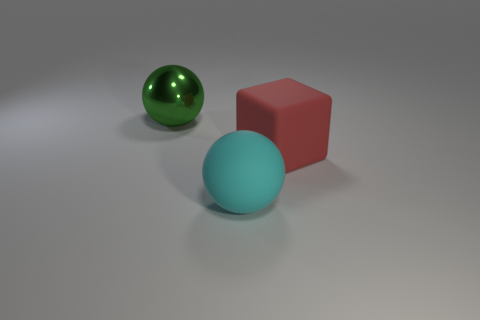There is another red object that is the same size as the metallic thing; what material is it?
Your response must be concise. Rubber. Are there more tiny blue shiny blocks than red blocks?
Your answer should be very brief. No. What number of other objects are there of the same color as the large matte cube?
Give a very brief answer. 0. What number of large balls are in front of the rubber cube and behind the large rubber block?
Offer a terse response. 0. Is there anything else that is the same size as the green shiny thing?
Your answer should be very brief. Yes. Are there more large things that are to the left of the large cyan object than large cyan things that are behind the red matte thing?
Offer a very short reply. Yes. There is a ball that is left of the rubber sphere; what is its material?
Provide a short and direct response. Metal. There is a red object; is its shape the same as the thing in front of the red cube?
Your answer should be compact. No. How many large objects are behind the ball that is on the right side of the large ball that is behind the red block?
Make the answer very short. 2. There is a shiny thing that is the same shape as the cyan matte object; what color is it?
Ensure brevity in your answer.  Green. 